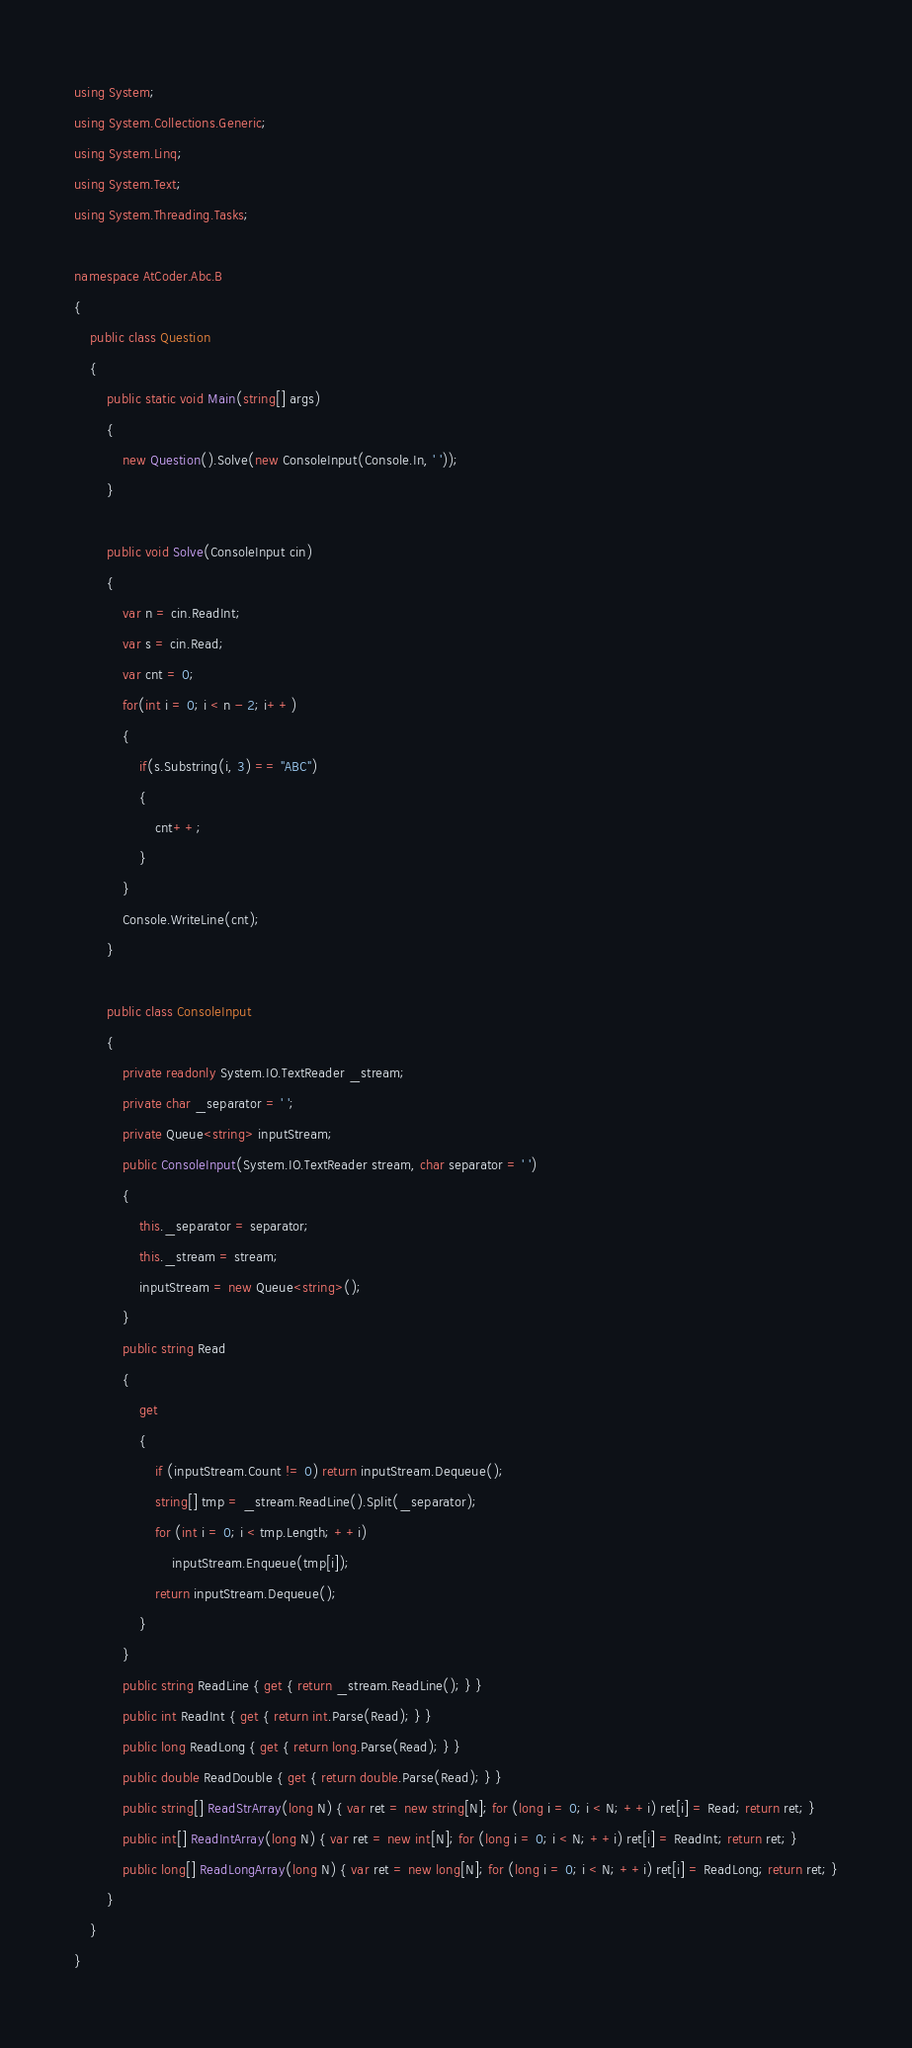Convert code to text. <code><loc_0><loc_0><loc_500><loc_500><_C#_>using System;
using System.Collections.Generic;
using System.Linq;
using System.Text;
using System.Threading.Tasks;

namespace AtCoder.Abc.B
{
    public class Question
    {
        public static void Main(string[] args)
        {
            new Question().Solve(new ConsoleInput(Console.In, ' '));
        }

        public void Solve(ConsoleInput cin)
        {
            var n = cin.ReadInt;
            var s = cin.Read;
            var cnt = 0;
            for(int i = 0; i < n - 2; i++)
            {
                if(s.Substring(i, 3) == "ABC")
                {
                    cnt++;
                }
            }
            Console.WriteLine(cnt);
        }

        public class ConsoleInput
        {
            private readonly System.IO.TextReader _stream;
            private char _separator = ' ';
            private Queue<string> inputStream;
            public ConsoleInput(System.IO.TextReader stream, char separator = ' ')
            {
                this._separator = separator;
                this._stream = stream;
                inputStream = new Queue<string>();
            }
            public string Read
            {
                get
                {
                    if (inputStream.Count != 0) return inputStream.Dequeue();
                    string[] tmp = _stream.ReadLine().Split(_separator);
                    for (int i = 0; i < tmp.Length; ++i)
                        inputStream.Enqueue(tmp[i]);
                    return inputStream.Dequeue();
                }
            }
            public string ReadLine { get { return _stream.ReadLine(); } }
            public int ReadInt { get { return int.Parse(Read); } }
            public long ReadLong { get { return long.Parse(Read); } }
            public double ReadDouble { get { return double.Parse(Read); } }
            public string[] ReadStrArray(long N) { var ret = new string[N]; for (long i = 0; i < N; ++i) ret[i] = Read; return ret; }
            public int[] ReadIntArray(long N) { var ret = new int[N]; for (long i = 0; i < N; ++i) ret[i] = ReadInt; return ret; }
            public long[] ReadLongArray(long N) { var ret = new long[N]; for (long i = 0; i < N; ++i) ret[i] = ReadLong; return ret; }
        }
    }
}
</code> 